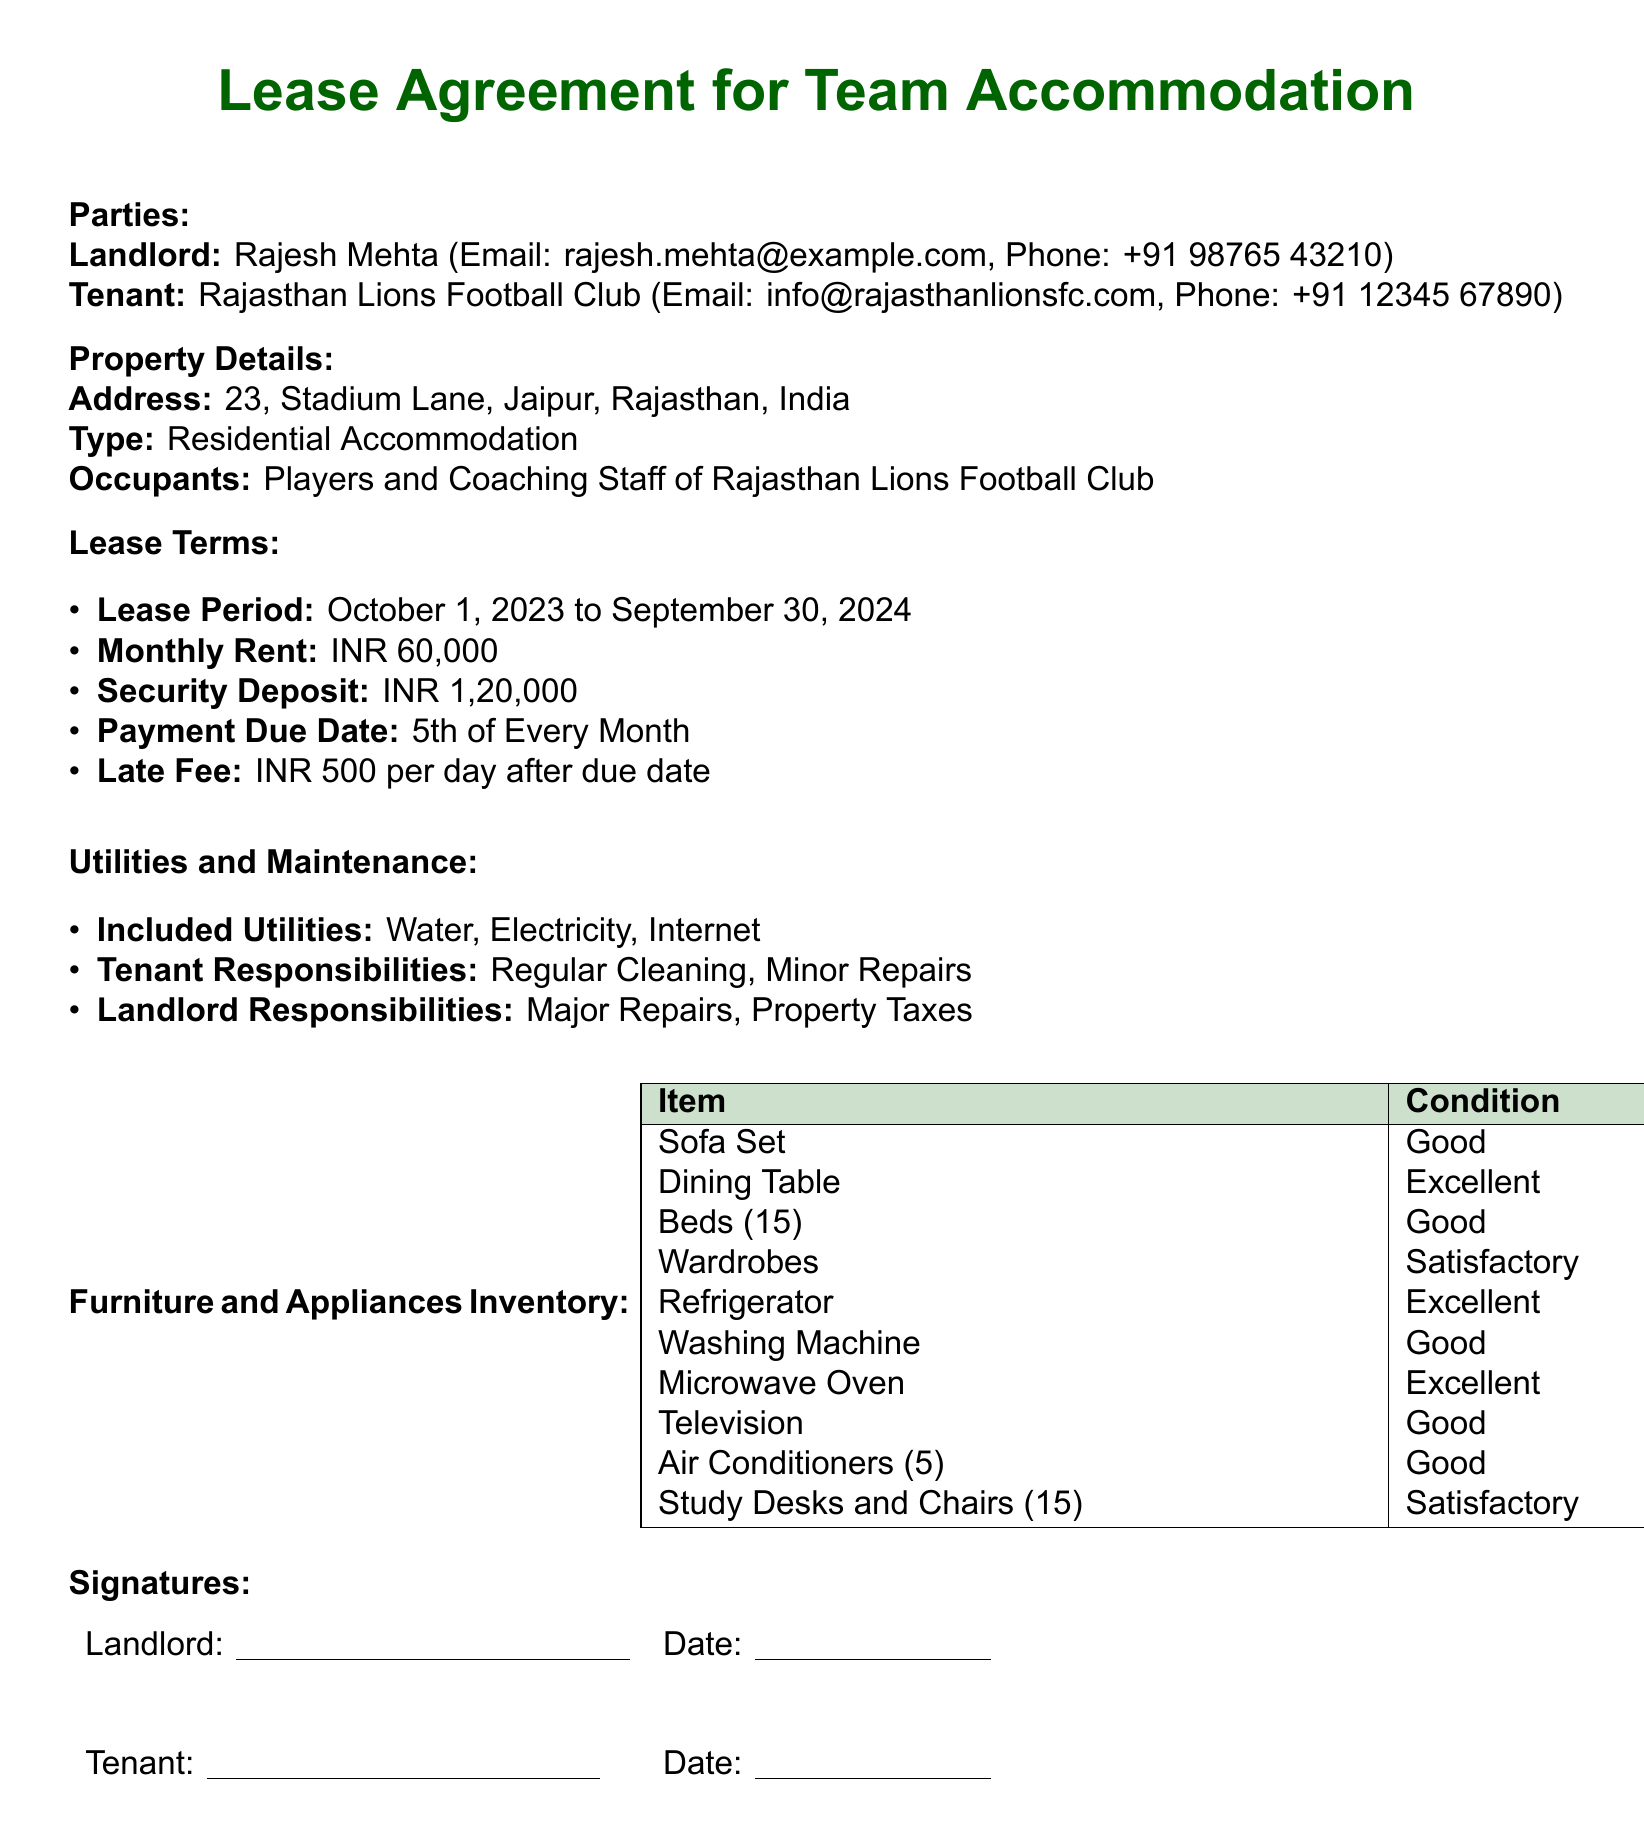What is the landlord's name? The landlord's name is mentioned in the document, specifying who the landlord is in the lease agreement.
Answer: Rajesh Mehta What is the monthly rent? The document provides a clear indication of the financial terms, including the specified monthly payment.
Answer: INR 60,000 What is the security deposit amount? This is a specific question regarding the financial arrangement for the lease, highlighted in the terms section.
Answer: INR 1,20,000 What is included in the utilities? This refers to the details provided in the utilities and maintenance section, outlining what is covered in the lease.
Answer: Water, Electricity, Internet How many beds are provided? The document specifies the number of beds included in the accommodation inventory, which is important for the tenant's requirements.
Answer: 15 What is the lease period's end date? This question focuses on understanding the duration of the lease as outlined in the document.
Answer: September 30, 2024 What is the late fee per day? This refers to the consequences of late payment as outlined in the lease terms, which is crucial for financial planning.
Answer: INR 500 per day What is the condition of the refrigerator? In the furniture and appliances inventory, the condition of each item is noted, providing important details for the tenant.
Answer: Excellent What is the number of air conditioners? This is a specific inquiry regarding the amenities provided in the rental property as per the inventory checklist.
Answer: 5 What are the tenant responsibilities? This question pertains to the obligations of the tenant, as specified in the utilities and maintenance section.
Answer: Regular Cleaning, Minor Repairs 